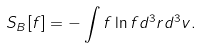Convert formula to latex. <formula><loc_0><loc_0><loc_500><loc_500>S _ { B } [ f ] = - \int f \ln f d ^ { 3 } { r } d ^ { 3 } { v } .</formula> 